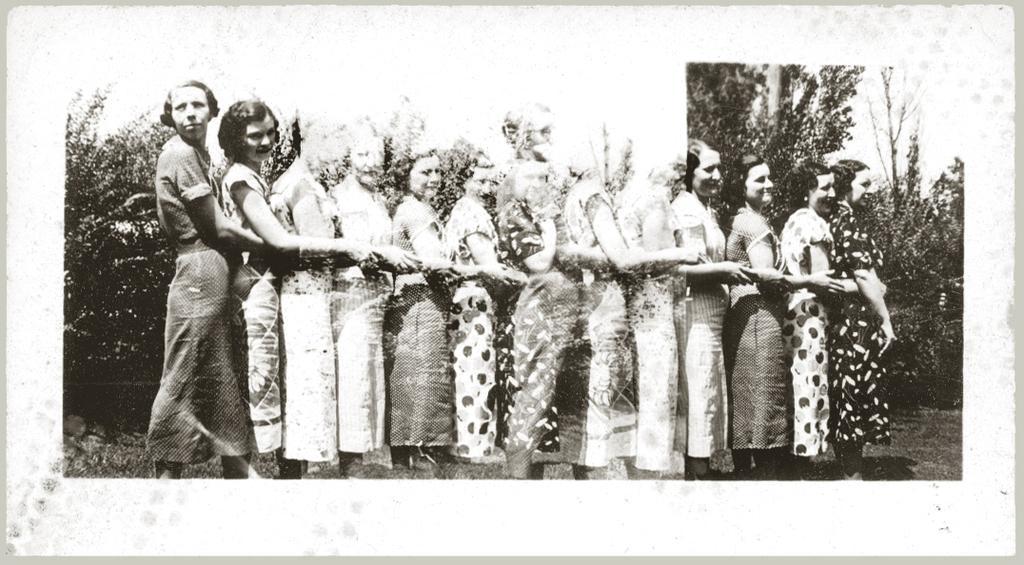Please provide a concise description of this image. This is a black and white image and I can see few women standing in a row holding their hands and this is an unclear image. 